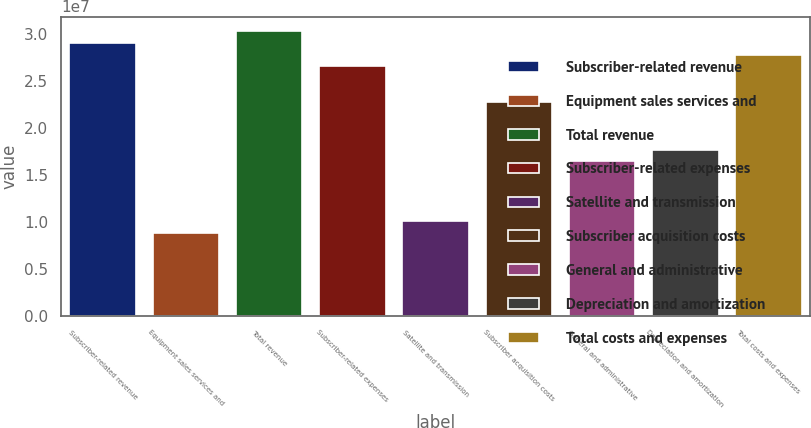Convert chart to OTSL. <chart><loc_0><loc_0><loc_500><loc_500><bar_chart><fcel>Subscriber-related revenue<fcel>Equipment sales services and<fcel>Total revenue<fcel>Subscriber-related expenses<fcel>Satellite and transmission<fcel>Subscriber acquisition costs<fcel>General and administrative<fcel>Depreciation and amortization<fcel>Total costs and expenses<nl><fcel>2.90737e+07<fcel>8.84852e+06<fcel>3.03378e+07<fcel>2.65456e+07<fcel>1.01126e+07<fcel>2.27533e+07<fcel>1.6433e+07<fcel>1.7697e+07<fcel>2.78096e+07<nl></chart> 